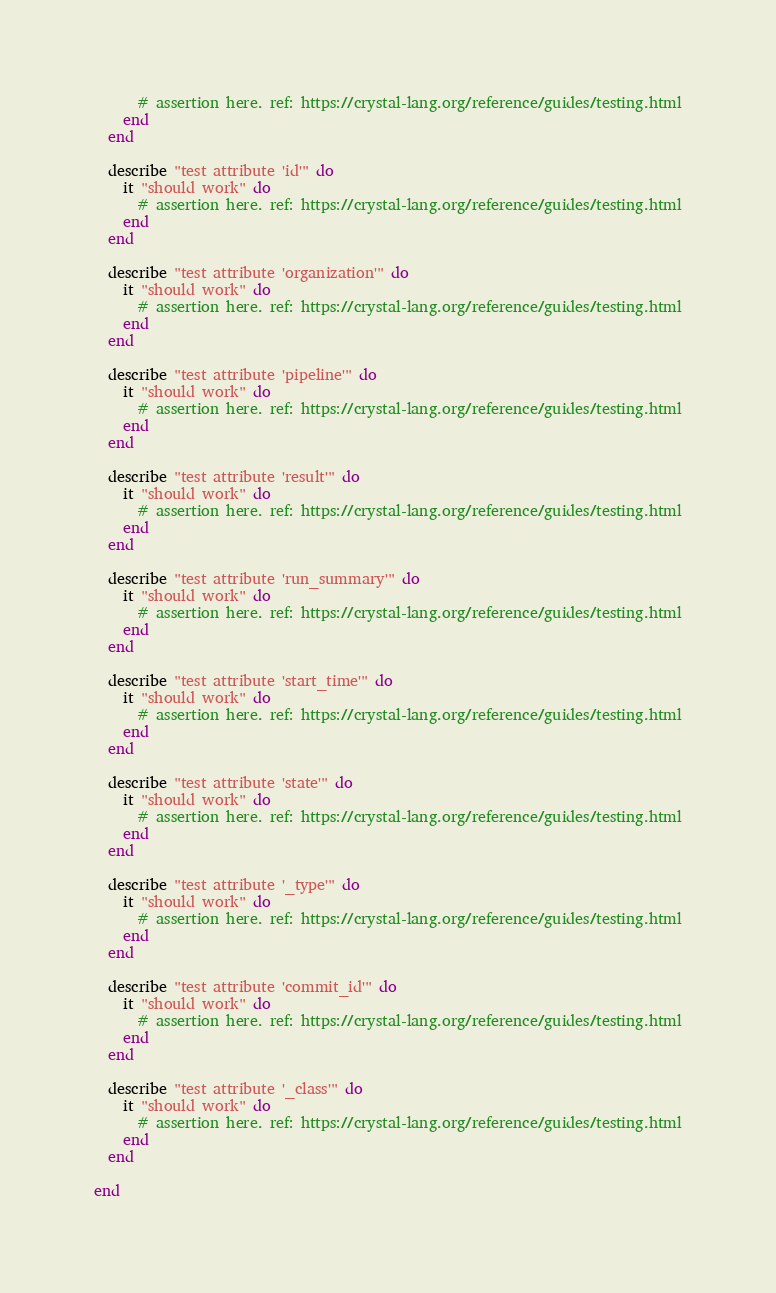Convert code to text. <code><loc_0><loc_0><loc_500><loc_500><_Crystal_>      # assertion here. ref: https://crystal-lang.org/reference/guides/testing.html
    end
  end

  describe "test attribute 'id'" do
    it "should work" do
      # assertion here. ref: https://crystal-lang.org/reference/guides/testing.html
    end
  end

  describe "test attribute 'organization'" do
    it "should work" do
      # assertion here. ref: https://crystal-lang.org/reference/guides/testing.html
    end
  end

  describe "test attribute 'pipeline'" do
    it "should work" do
      # assertion here. ref: https://crystal-lang.org/reference/guides/testing.html
    end
  end

  describe "test attribute 'result'" do
    it "should work" do
      # assertion here. ref: https://crystal-lang.org/reference/guides/testing.html
    end
  end

  describe "test attribute 'run_summary'" do
    it "should work" do
      # assertion here. ref: https://crystal-lang.org/reference/guides/testing.html
    end
  end

  describe "test attribute 'start_time'" do
    it "should work" do
      # assertion here. ref: https://crystal-lang.org/reference/guides/testing.html
    end
  end

  describe "test attribute 'state'" do
    it "should work" do
      # assertion here. ref: https://crystal-lang.org/reference/guides/testing.html
    end
  end

  describe "test attribute '_type'" do
    it "should work" do
      # assertion here. ref: https://crystal-lang.org/reference/guides/testing.html
    end
  end

  describe "test attribute 'commit_id'" do
    it "should work" do
      # assertion here. ref: https://crystal-lang.org/reference/guides/testing.html
    end
  end

  describe "test attribute '_class'" do
    it "should work" do
      # assertion here. ref: https://crystal-lang.org/reference/guides/testing.html
    end
  end

end
</code> 